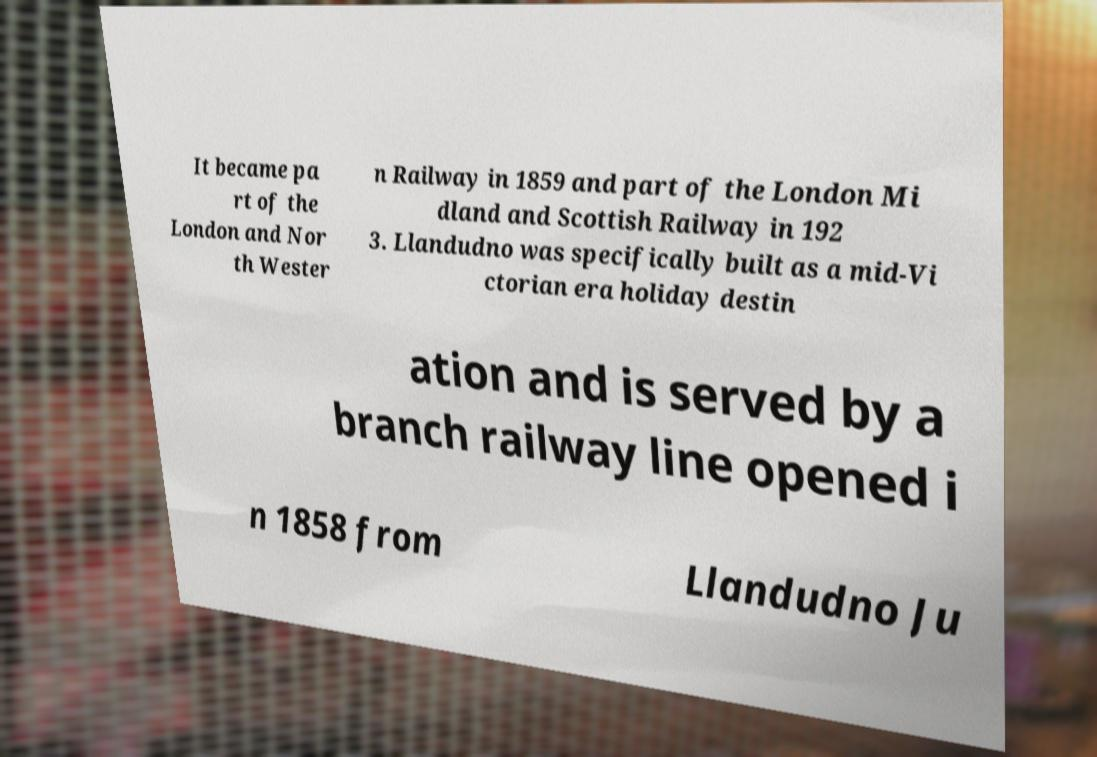I need the written content from this picture converted into text. Can you do that? It became pa rt of the London and Nor th Wester n Railway in 1859 and part of the London Mi dland and Scottish Railway in 192 3. Llandudno was specifically built as a mid-Vi ctorian era holiday destin ation and is served by a branch railway line opened i n 1858 from Llandudno Ju 